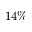Convert formula to latex. <formula><loc_0><loc_0><loc_500><loc_500>1 4 \%</formula> 